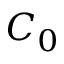Convert formula to latex. <formula><loc_0><loc_0><loc_500><loc_500>C _ { 0 }</formula> 